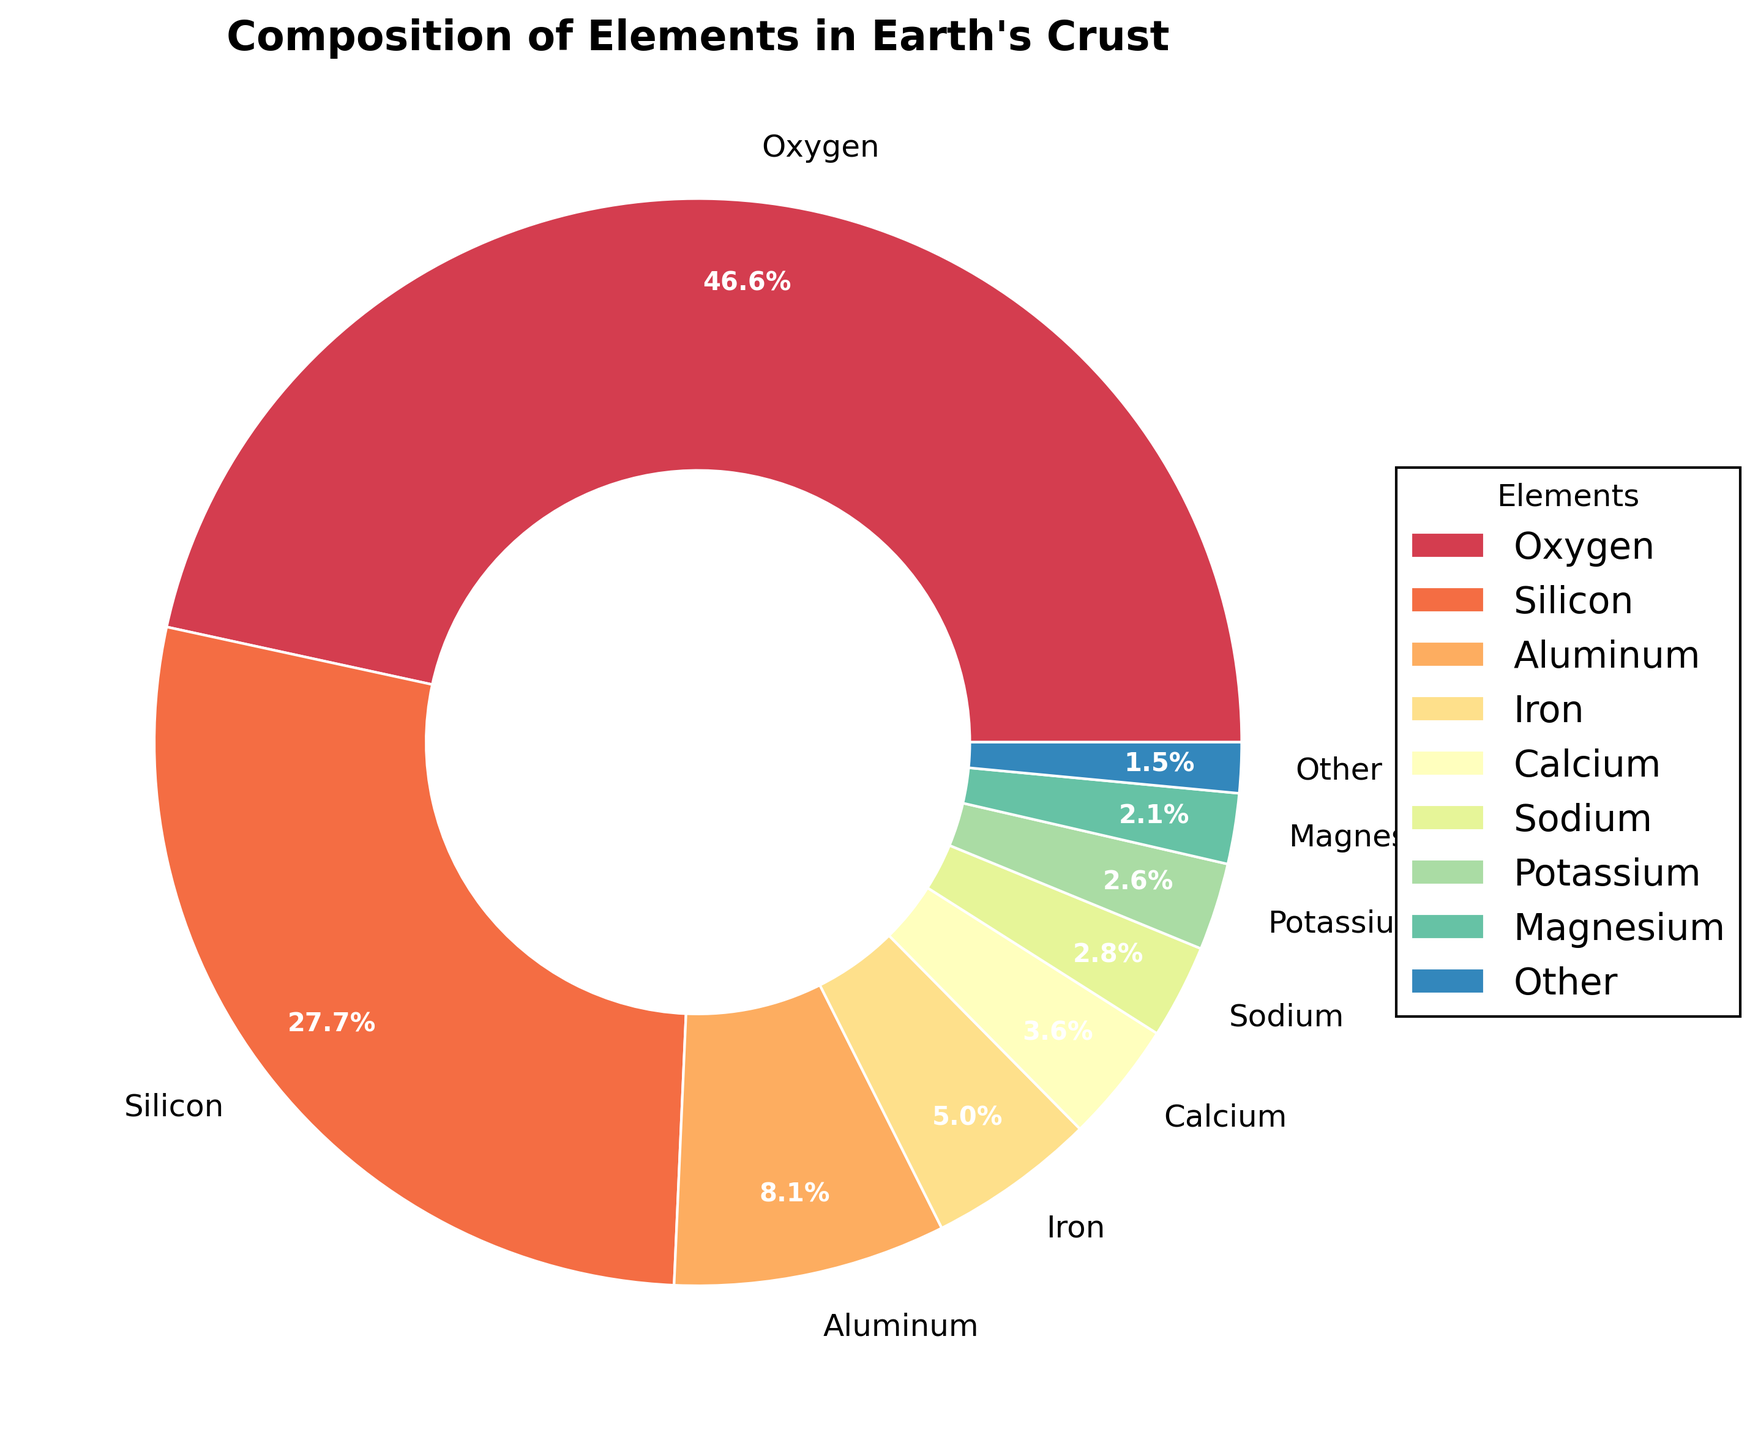What is the combined percentage of Silicon and Aluminum in Earth's crust? To find the combined percentage, sum the individual percentages of Silicon (27.7%) and Aluminum (8.1%). So, 27.7 + 8.1 = 35.8.
Answer: 35.8% Which element has the second highest percentage in the Earth's crust? The element with the highest percentage is Oxygen at 46.6%. The element with the next highest percentage after Oxygen is Silicon at 27.7%.
Answer: Silicon How much higher is the percentage of Oxygen compared to Iron? Subtract the percentage of Iron (5.0%) from the percentage of Oxygen (46.6%). So, 46.6 - 5.0 = 41.6.
Answer: 41.6% What are the top three elements in terms of percentage by composition in the Earth's crust? The top three elements by percentage are Oxygen (46.6%), Silicon (27.7%), and Aluminum (8.1%).
Answer: Oxygen, Silicon, Aluminum What is the percentage of elements composed of less than 1% each in the Earth's crust? The elements Titanium, Hydrogen, Carbon, Phosphorus, Sulfur, and other elements each have percentages below 1%. The "Other" category in the pie chart summarizes them into one group. The percentage of this "Other" group is 1.5%.
Answer: 1.5% Which element has the smallest visual segment in the pie chart? The element with the smallest visual segment is Sulfur, with a percentage of 0.05%, which is included in the "Other" category.
Answer: Sulfur How does the percentage of Potassium compare to that of Sodium in the Earth's crust? The percentage of Potassium is 2.6%, and the percentage of Sodium is 2.8%. Potassium is slightly less than Sodium. Thus, Sodium has a higher percentage than Potassium.
Answer: Sodium is higher What is the total percentage of all elements except for Oxygen and Silicon in the Earth's crust? First, sum the percentages of all elements except Oxygen and Silicon: Aluminum (8.1%), Iron (5.0%), Calcium (3.6%), Sodium (2.8%), Potassium (2.6%), Magnesium (2.1%), and the "Other" category (1.5%). Summing these: 8.1 + 5.0 + 3.6 + 2.8 + 2.6 + 2.1 + 1.5 = 25.7.
Answer: 25.7% What color represents the element Magnesium in the pie chart? Referring to the pie chart's color scheme, Magnesium is represented by a shade of dark yellow.
Answer: Dark Yellow 